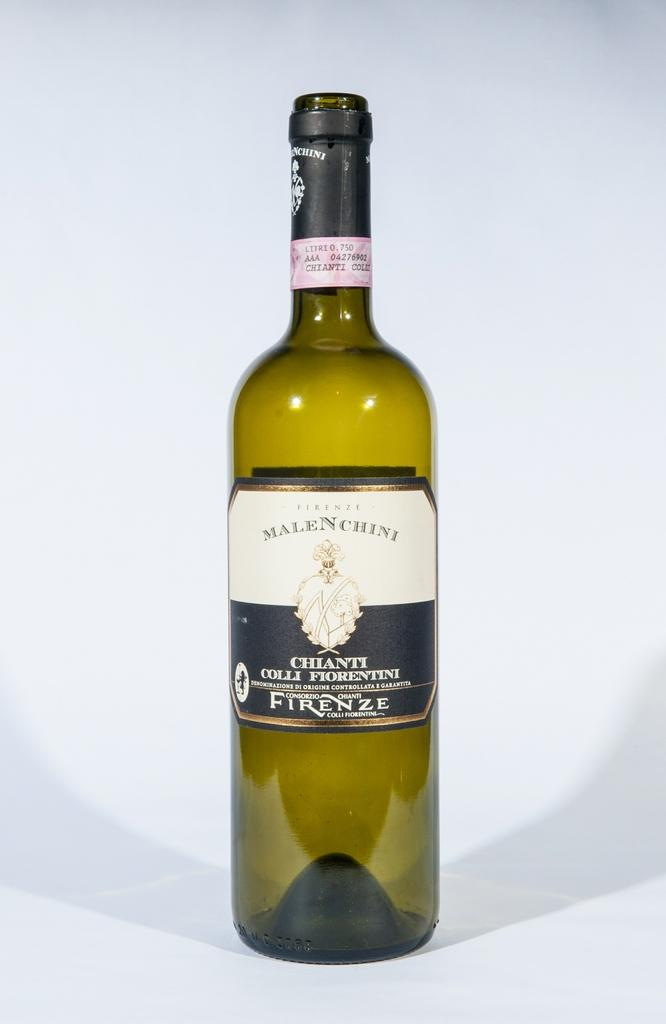<image>
Present a compact description of the photo's key features. A bottle of Firenze liquor sits on a blank white surface. 